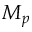Convert formula to latex. <formula><loc_0><loc_0><loc_500><loc_500>M _ { p }</formula> 